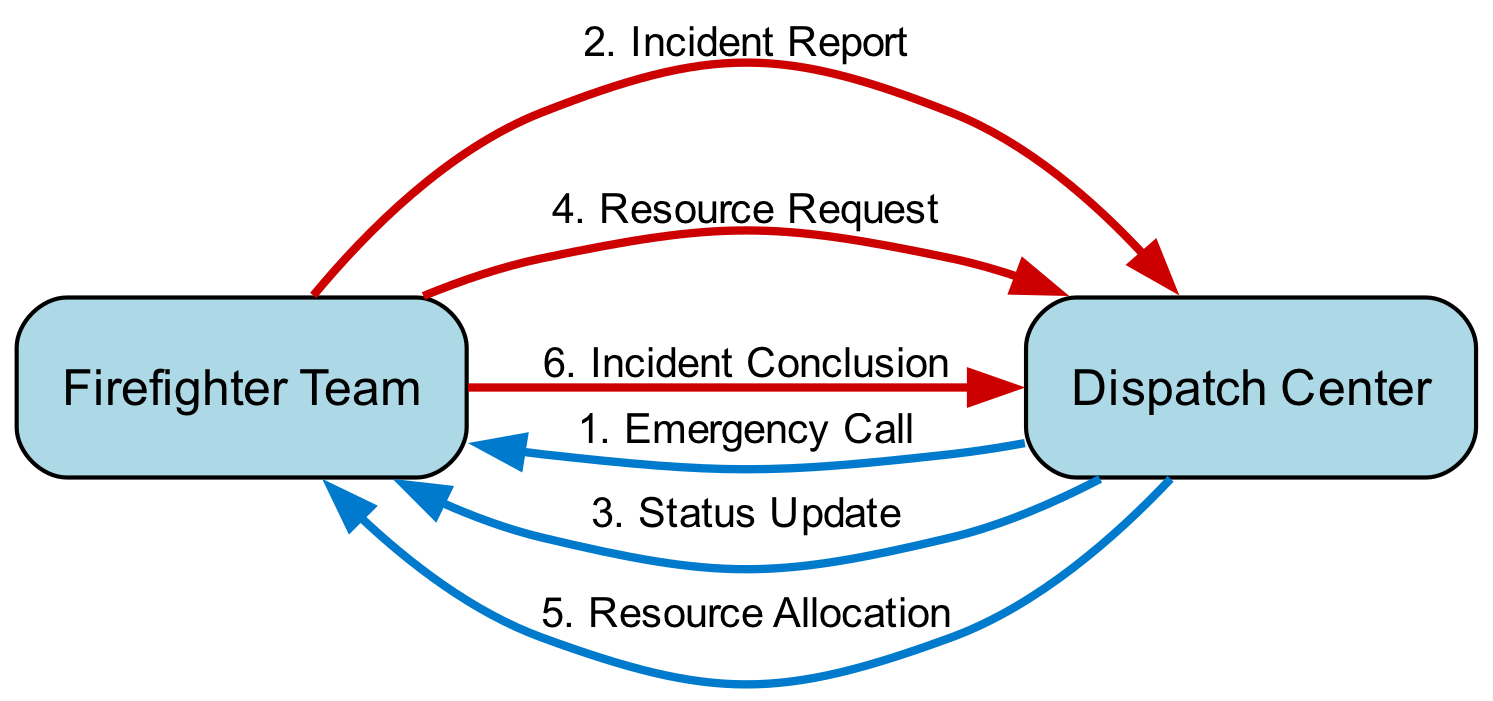What's the first message sent in the communication flow? The communication flow starts with the "Emergency Call" message, which is the initial message received by the dispatch center.
Answer: Emergency Call How many actors are there in the diagram? The diagram contains two actors: the Firefighter Team and the Dispatch Center.
Answer: 2 What message is sent from the Dispatch Center to the Firefighter Team after the initial call? After receiving the initial emergency call, the Dispatch Center sends an "Incident Report" to the Firefighter Team.
Answer: Incident Report What message indicates ongoing communication from the Firefighter Team to Dispatch? The "Status Update" is the message that signifies ongoing communication from the Firefighter Team to the Dispatch Center.
Answer: Status Update What is the last message sent back to Dispatch from the Firefighter Team? The final message sent from the Firefighter Team to the Dispatch Center is the "Incident Conclusion," marking the resolution of the incident.
Answer: Incident Conclusion How many messages are sent from Dispatch to the Firefighter Team? There are four messages sent from Dispatch to the Firefighter Team: Emergency Call, Incident Report, Resource Allocation, and Incident Conclusion.
Answer: 4 What type of request does the Firefighter Team make to Dispatch during the incident? The Firefighter Team makes a "Resource Request" to dispatch, indicating the need for additional support or resources.
Answer: Resource Request Which message is related to confirming additional resources? The "Resource Allocation" message is related to confirming the additional resources requested by the Firefighter Team.
Answer: Resource Allocation What color represents messages sent from Dispatch to the Firefighter Team? Messages sent from Dispatch to the Firefighter Team are represented by a blue color in the diagram.
Answer: Blue 